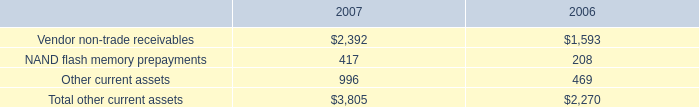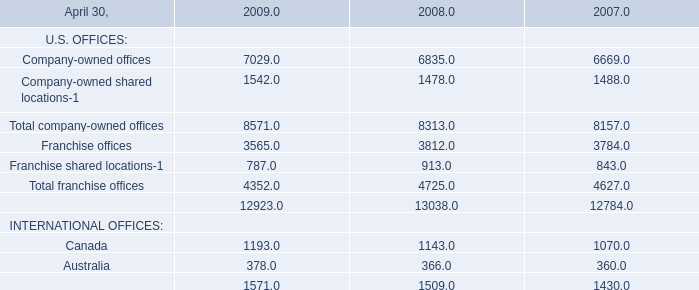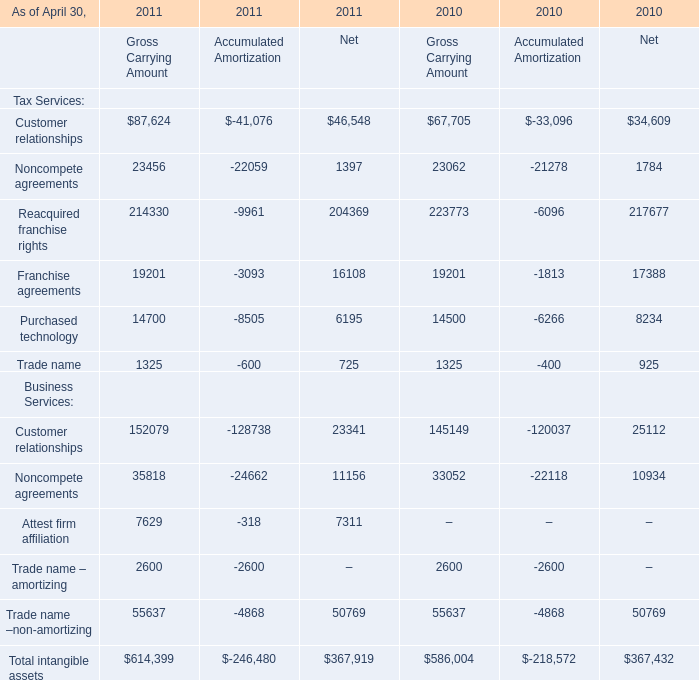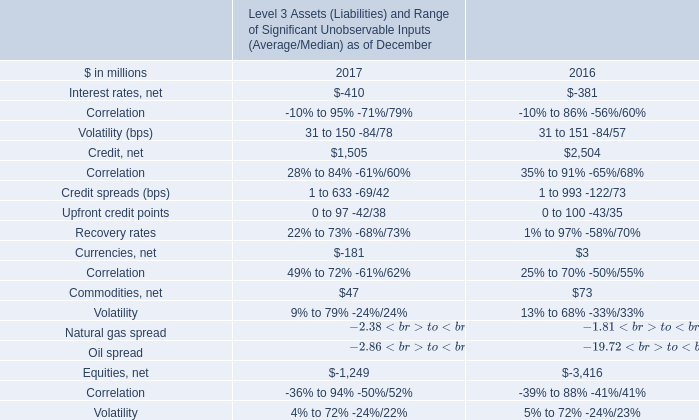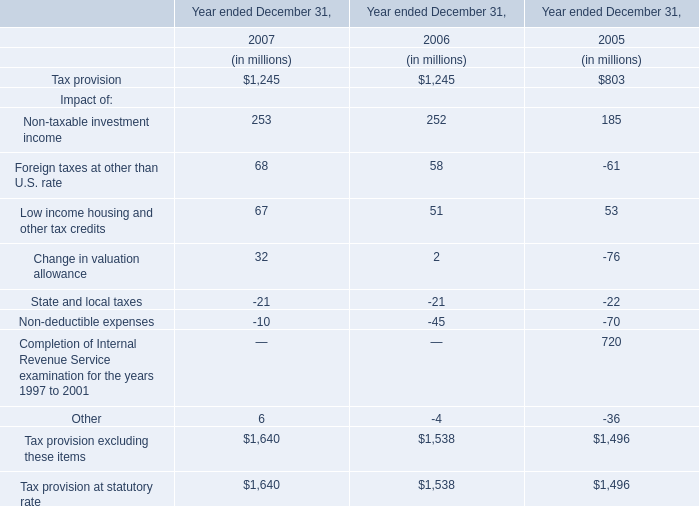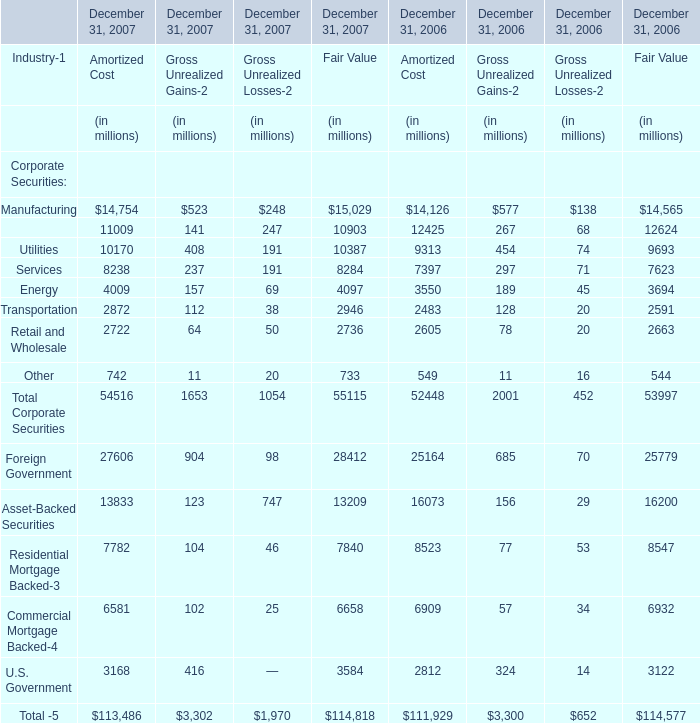What is the sum of elements for Gross Carrying Amount in the range of 50000 and 300000 in 2010? 
Computations: (((67705 + 223773) + 145149) + 55637)
Answer: 492264.0. 